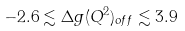<formula> <loc_0><loc_0><loc_500><loc_500>- 2 . 6 \lesssim \Delta g ( Q ^ { 2 } ) _ { o f f } \lesssim 3 . 9</formula> 